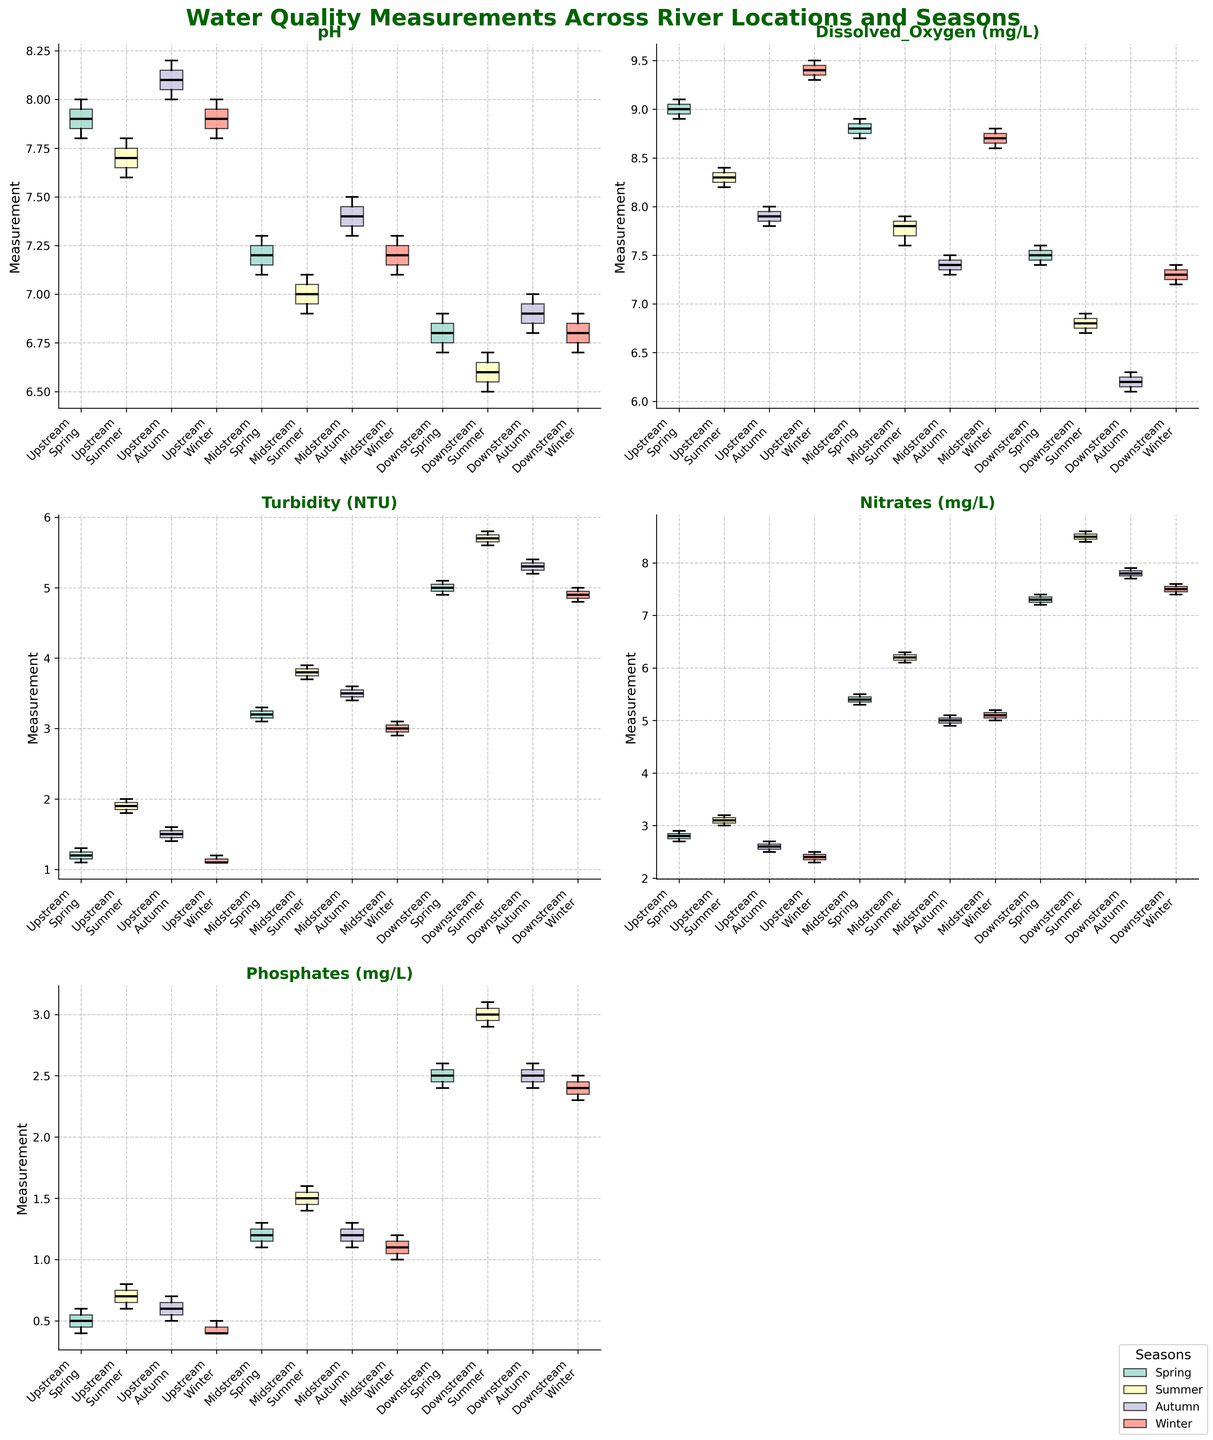What is the title of the figure? The title of the figure is directly above all subplots and usually describes the main subject of the plots. By looking at the top-centered text in bold, you can find the title "Water Quality Measurements Across River Locations and Seasons."
Answer: Water Quality Measurements Across River Locations and Seasons Which parameter shows the most significant seasonal variation across all locations? To determine significant seasonal variation, observe the spread and positions of the box plots across different seasons. Turbidity (NTU) shows a noticeable change, particularly high in the downstream location during summer.
Answer: Turbidity (NTU) How does the pH level vary between upstream and downstream locations in spring? Look at the pH box plots for upstream and downstream in spring. The upstream pH values are around 7.8-8.0, whereas downstream pH values are around 6.7-6.9.
Answer: Upstream: 7.8-8.0; Downstream: 6.7-6.9 Which season has the highest median dissolved oxygen level at the upstream location? By examining the central lines (medians) of the upstream box plots for dissolved oxygen across different seasons, you can see that winter has the highest median level.
Answer: Winter Compare the nitrate levels downstream in summer and winter. Evaluate the positioning and spread of the box plots for nitrates in the downstream location for summer and winter. Summer levels are around 8.4-8.6 mg/L, whereas winter levels are around 7.4-7.6 mg/L.
Answer: Summer: 8.4-8.6 mg/L; Winter: 7.4-7.6 mg/L Which location shows the highest turbidity during any season and in which season is it? Identify the highest box plot for turbidity across all locations and seasons. The highest turbidity is downstream during summer.
Answer: Downstream, Summer What's the range of phosphate levels in the midstream location during autumn? The range of phosphate levels can be calculated by subtracting the smallest value from the largest value in the midstream autumn box plot. It ranges from 1.1 to 1.3 mg/L.
Answer: 0.2 mg/L Which season shows the highest median pH value in the upstream location? Compare the medians (central lines) in the upstream pH box plots across the seasons. Autumn shows the highest median pH value.
Answer: Autumn Which location has the lowest dissolved oxygen levels during any season? Identify the box plots with the lowest median lines for dissolved oxygen. The lowest levels are at the downstream location during summer.
Answer: Downstream, Summer Do nitrate levels increase or decrease from upstream to downstream during spring? By examining the nitrate box plots for spring across all locations, it's visible that nitrates increase from upstream (around 2.7-2.9 mg/L) to downstream (around 7.2-7.4 mg/L).
Answer: Increase 